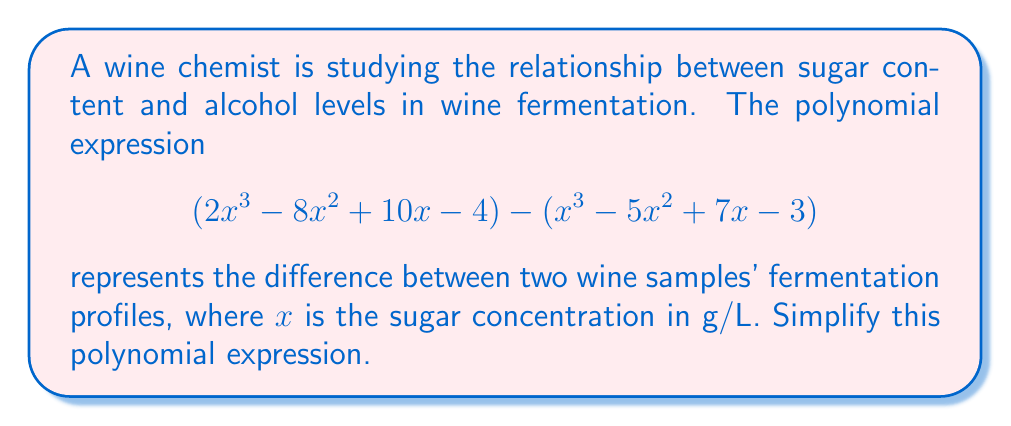Help me with this question. To simplify this polynomial expression, we need to subtract the second polynomial from the first. Let's approach this step-by-step:

1) First, let's identify the polynomials:
   P1 = $2x^3 - 8x^2 + 10x - 4$
   P2 = $x^3 - 5x^2 + 7x - 3$

2) We need to subtract P2 from P1. When subtracting polynomials, we subtract the coefficients of like terms:

   $$(2x^3 - 8x^2 + 10x - 4) - (x^3 - 5x^2 + 7x - 3)$$

3) Distribute the negative sign to all terms in the second polynomial:

   $$2x^3 - 8x^2 + 10x - 4 - x^3 + 5x^2 - 7x + 3$$

4) Now, we can rearrange the terms to group like terms together:

   $$(2x^3 - x^3) + (-8x^2 + 5x^2) + (10x - 7x) + (-4 + 3)$$

5) Simplify by combining like terms:

   $$x^3 - 3x^2 + 3x - 1$$

This simplified polynomial represents the difference in fermentation profiles between the two wine samples.
Answer: $x^3 - 3x^2 + 3x - 1$ 